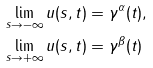Convert formula to latex. <formula><loc_0><loc_0><loc_500><loc_500>\lim _ { s \to - \infty } u ( s , t ) & = \gamma ^ { \alpha } ( t ) , \\ \lim _ { s \to + \infty } u ( s , t ) & = \gamma ^ { \beta } ( t )</formula> 